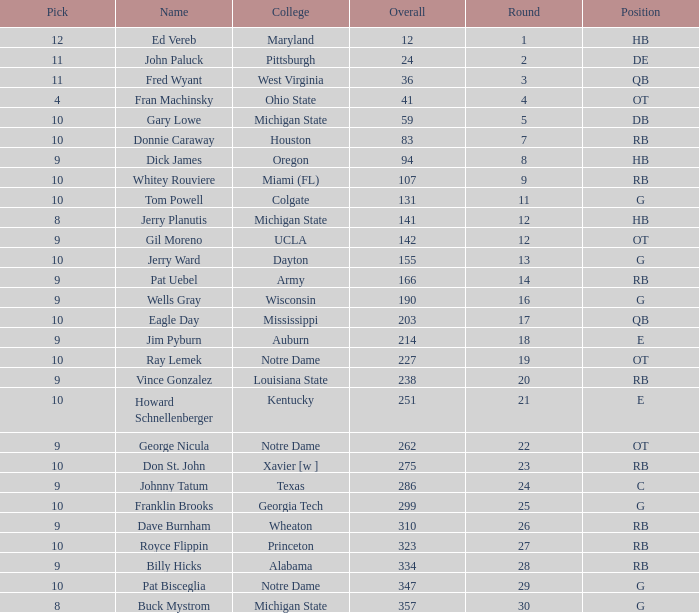What is the highest overall pick number for george nicula who had a pick smaller than 9? None. 